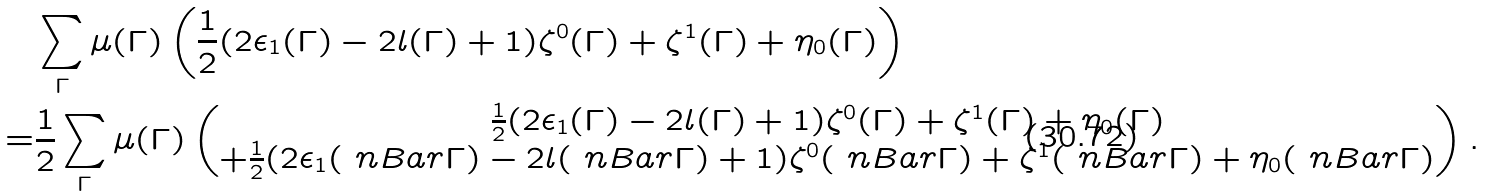<formula> <loc_0><loc_0><loc_500><loc_500>& \sum _ { \Gamma } \mu ( \Gamma ) \left ( \frac { 1 } { 2 } ( 2 \epsilon _ { 1 } ( \Gamma ) - 2 l ( \Gamma ) + 1 ) \zeta ^ { 0 } ( \Gamma ) + \zeta ^ { 1 } ( \Gamma ) + \eta _ { 0 } ( \Gamma ) \right ) \\ = & \frac { 1 } { 2 } \sum _ { \Gamma } \mu ( \Gamma ) \begin{pmatrix} \frac { 1 } { 2 } ( 2 \epsilon _ { 1 } ( \Gamma ) - 2 l ( \Gamma ) + 1 ) \zeta ^ { 0 } ( \Gamma ) + \zeta ^ { 1 } ( \Gamma ) + \eta _ { 0 } ( \Gamma ) \\ + \frac { 1 } { 2 } ( 2 \epsilon _ { 1 } ( \ n B a r { \Gamma } ) - 2 l ( \ n B a r { \Gamma } ) + 1 ) \zeta ^ { 0 } ( \ n B a r { \Gamma } ) + \zeta ^ { 1 } ( \ n B a r { \Gamma } ) + \eta _ { 0 } ( \ n B a r { \Gamma } ) \end{pmatrix} .</formula> 